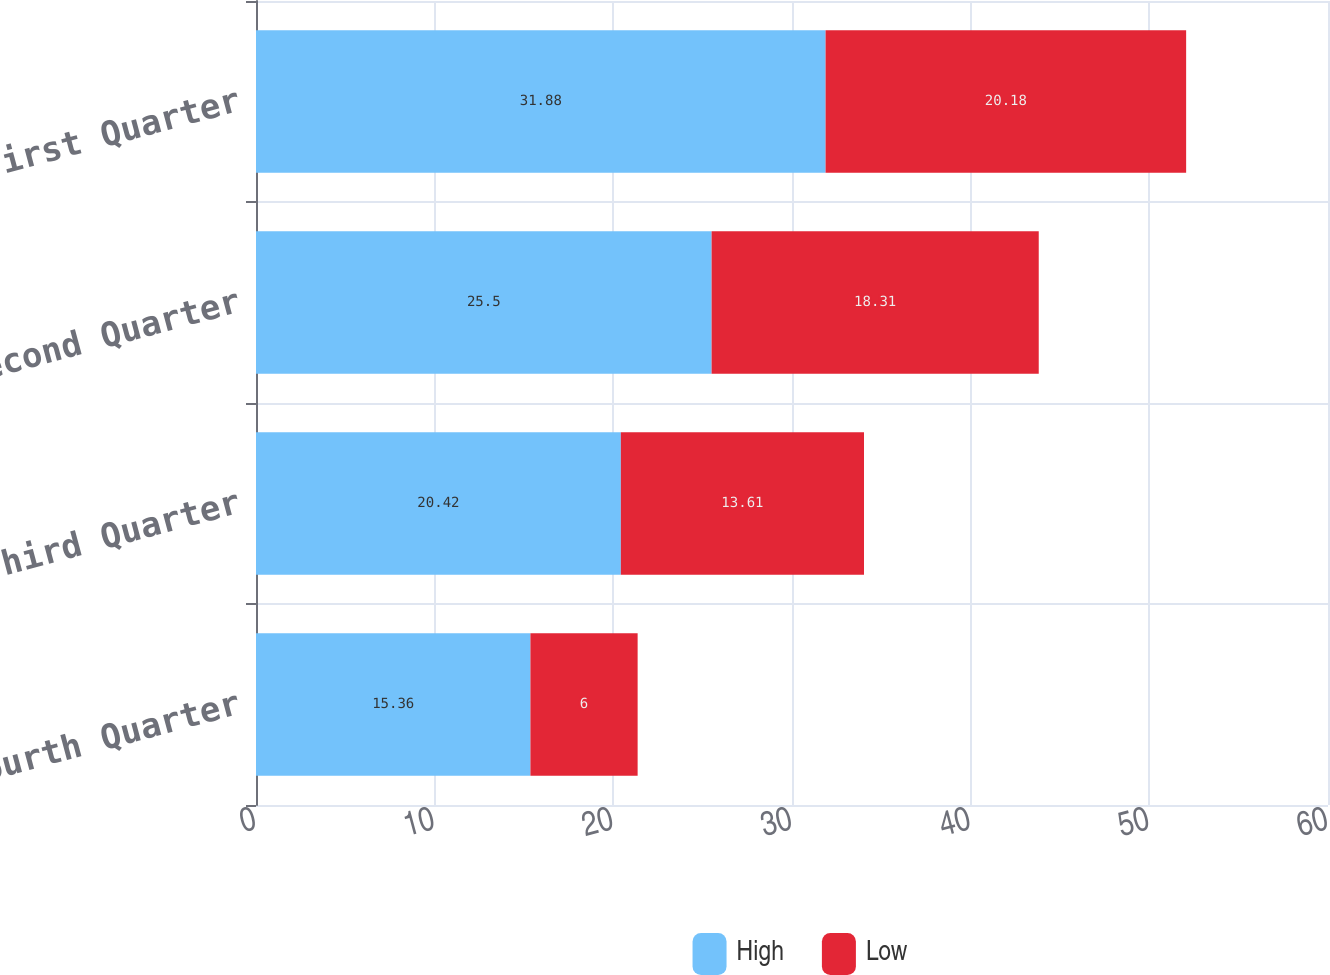Convert chart. <chart><loc_0><loc_0><loc_500><loc_500><stacked_bar_chart><ecel><fcel>Fourth Quarter<fcel>Third Quarter<fcel>Second Quarter<fcel>First Quarter<nl><fcel>High<fcel>15.36<fcel>20.42<fcel>25.5<fcel>31.88<nl><fcel>Low<fcel>6<fcel>13.61<fcel>18.31<fcel>20.18<nl></chart> 